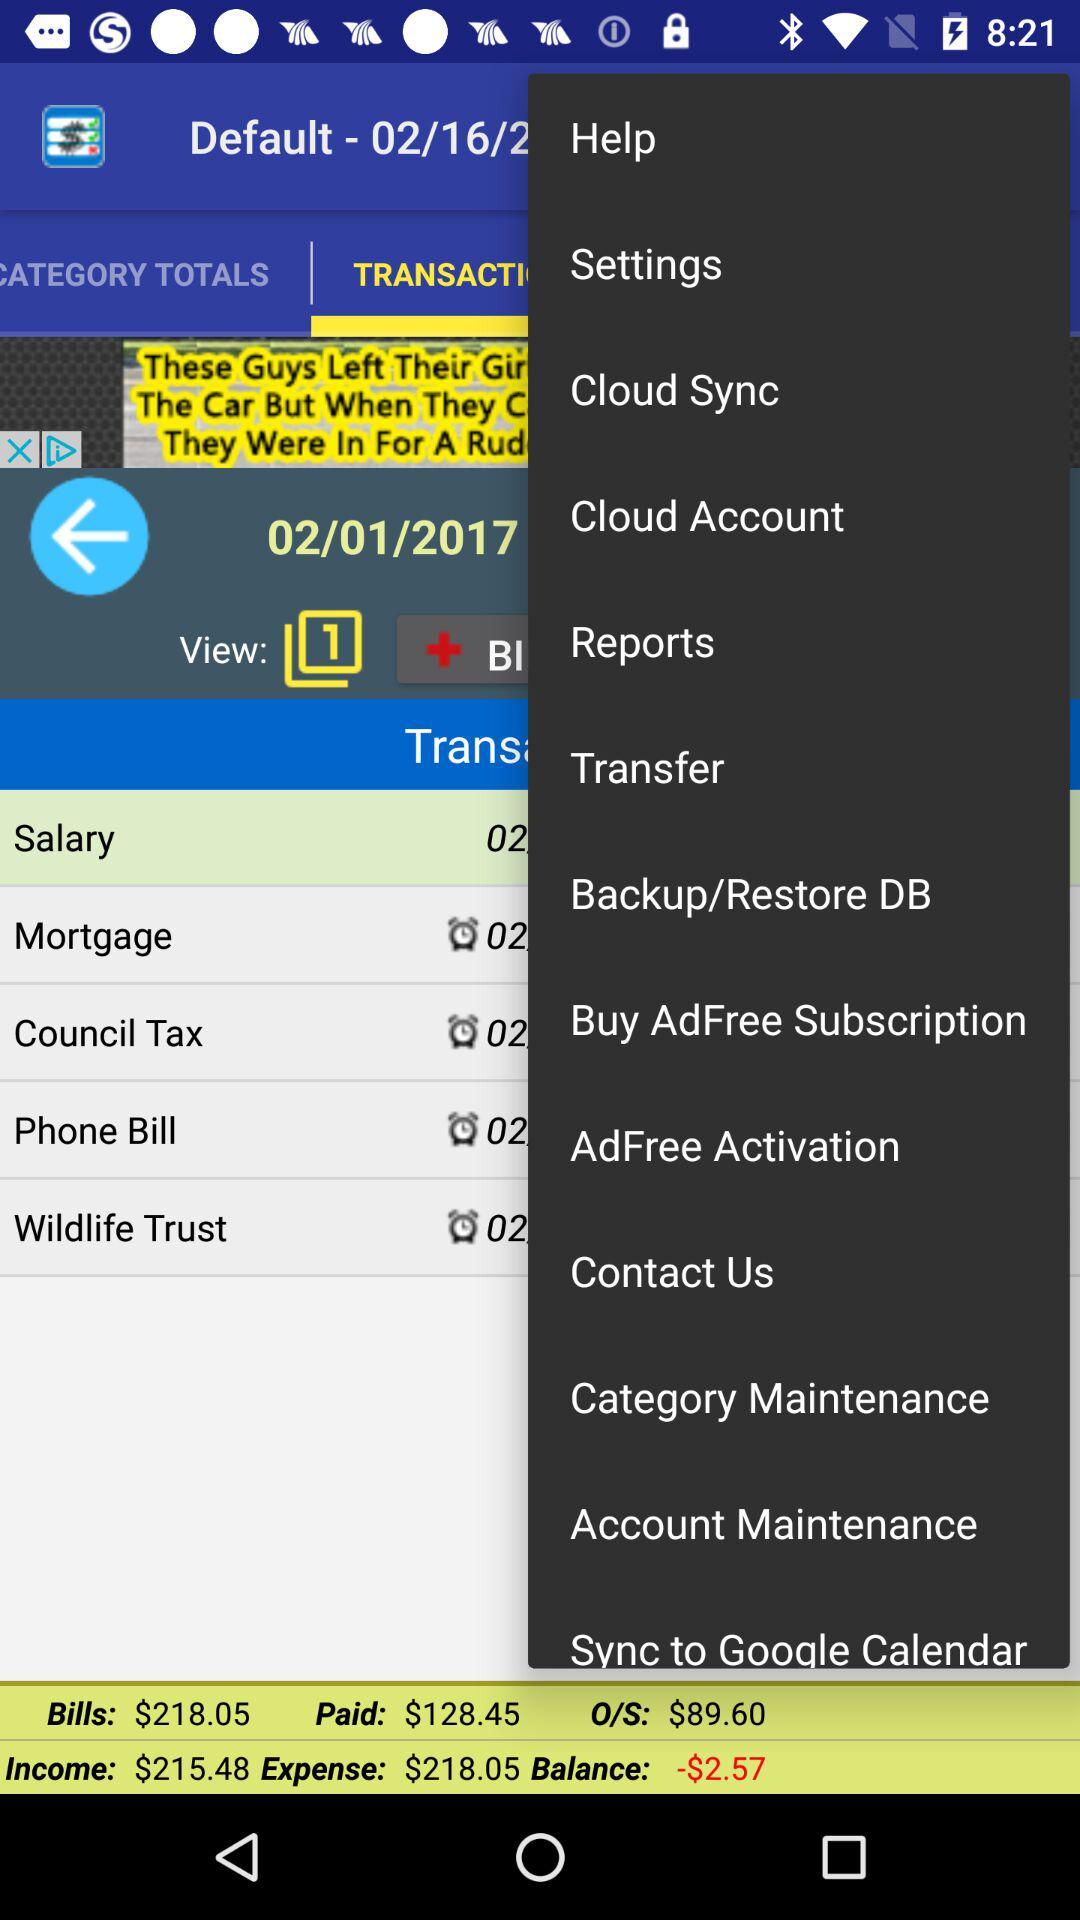How much more is the income than the expense?
Answer the question using a single word or phrase. -2.57 